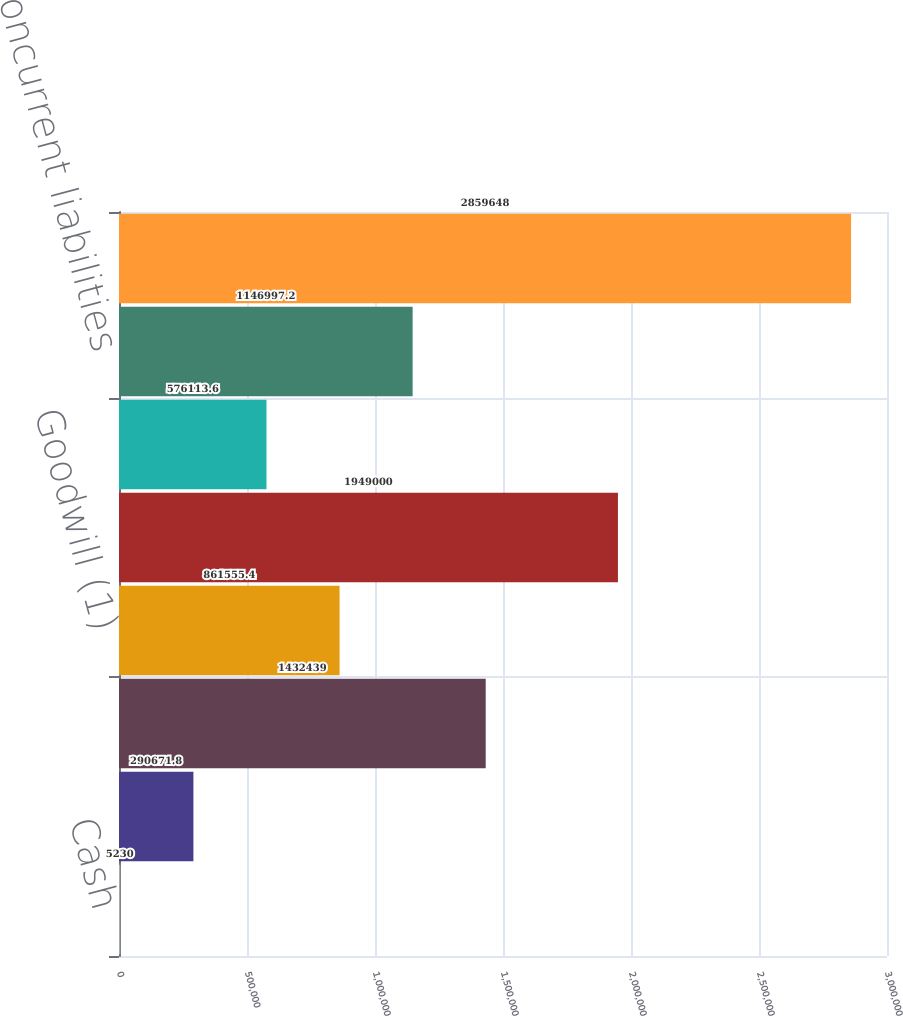<chart> <loc_0><loc_0><loc_500><loc_500><bar_chart><fcel>Cash<fcel>Current and noncurrent assets<fcel>Property and equipment<fcel>Goodwill (1)<fcel>FCC authorizations<fcel>Current liabilities<fcel>Noncurrent liabilities<fcel>Total acquisition<nl><fcel>5230<fcel>290672<fcel>1.43244e+06<fcel>861555<fcel>1.949e+06<fcel>576114<fcel>1.147e+06<fcel>2.85965e+06<nl></chart> 